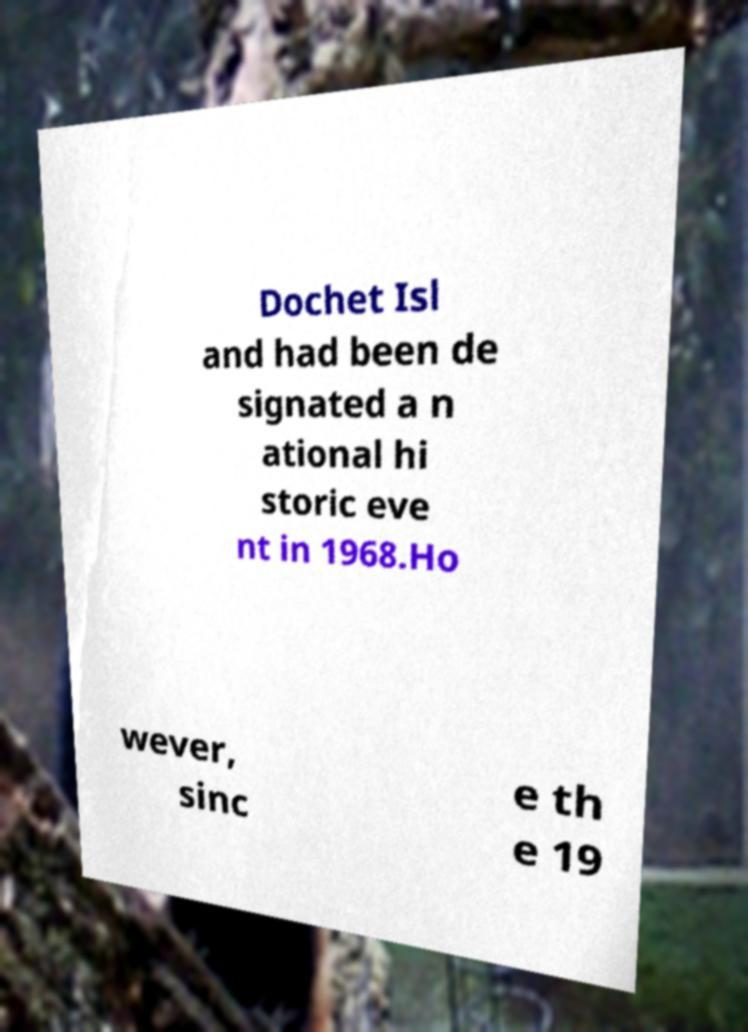Can you accurately transcribe the text from the provided image for me? Dochet Isl and had been de signated a n ational hi storic eve nt in 1968.Ho wever, sinc e th e 19 